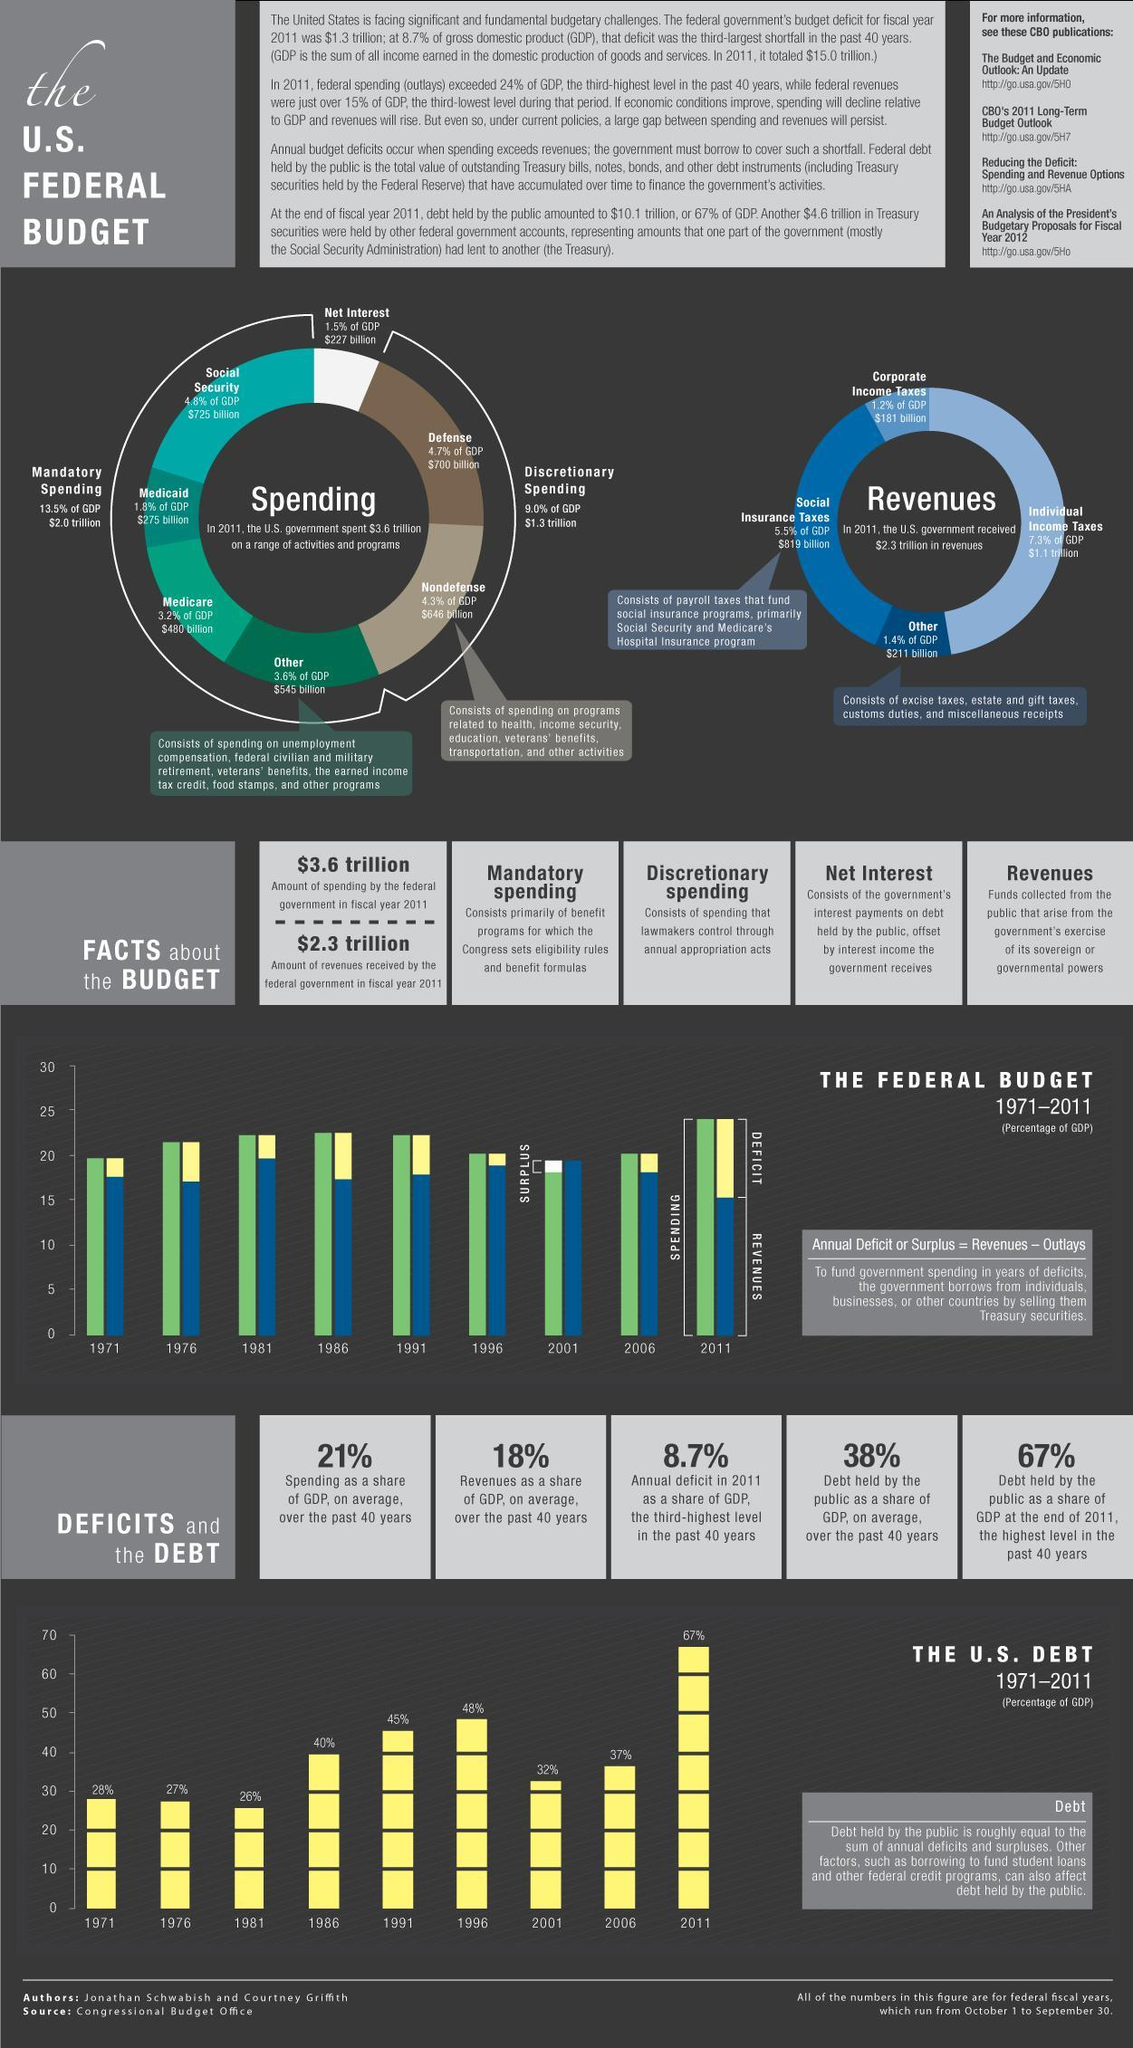What is the amount of individual income taxes received by the US government in 2011?
Answer the question with a short phrase. $1.1 trillion What was the amount of spending by the the Federal government in the fiscal year 2011? $3.6 trillion What is the main source of revenue for the US government? Individual income taxes What is the spending controlled by the lawmakers called? Discretionary spending What is the amount of revenues received by the Federal government in the fiscal year 2011? $2.3 trillion What is the amount spend on Social Security? $725 billion What are the three main sources of revenue for the US government? Individual income taxes, social insurance taxes, corporate income taxes Into which two groups can the spendings of US government be classified? Mandatory spending, discretionary spending In which year did the Federal government make a "surplus"? 2001 What is the amount of discretionary spending in 2011? $1.3 trillion In which years were the debt held by the public lower than 30%? 1971, 1976, 1981 What is the percentage of debts held by the public in 1996? 48% What is the amount of social insurance taxes received by the US government in 2011? $ 819 billion What was the percentage of debt held by the public in 2011? 67% What was the net interest paid by the US government in 2011? $227 billion What is the percentage of debt held by the public as a share of GDP over the past 40 years? 38% What is the percentage of revenues as a share of GDP over the past 40 years? 18% Over the past forty years, in "which year"  was the percentage of debt held by the public, the lowest? 1981 In which year was the deficit the highest? 2011 How much did the US government spend in total on Medicaid and Medicare in 2011($ billion)? 755 